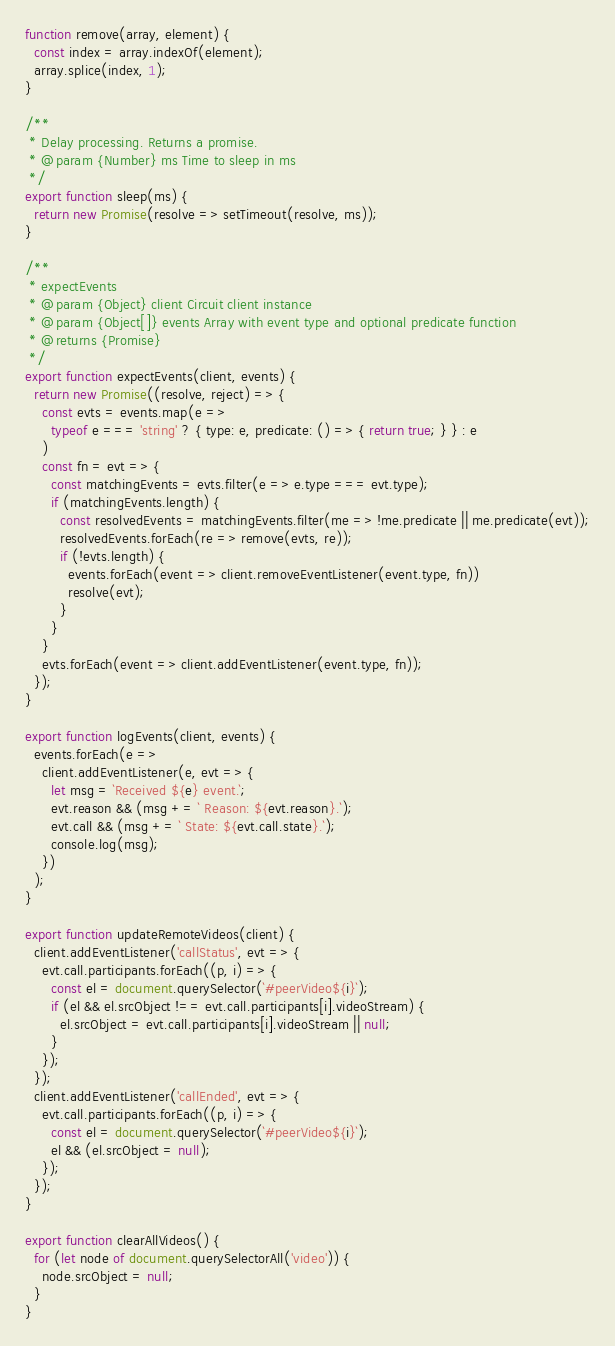Convert code to text. <code><loc_0><loc_0><loc_500><loc_500><_JavaScript_>
function remove(array, element) {
  const index = array.indexOf(element);
  array.splice(index, 1);
}

/**
 * Delay processing. Returns a promise.
 * @param {Number} ms Time to sleep in ms
 */
export function sleep(ms) {
  return new Promise(resolve => setTimeout(resolve, ms));
}

/**
 * expectEvents
 * @param {Object} client Circuit client instance
 * @param {Object[]} events Array with event type and optional predicate function
 * @returns {Promise}
 */
export function expectEvents(client, events) {
  return new Promise((resolve, reject) => {
    const evts = events.map(e =>
      typeof e === 'string' ? { type: e, predicate: () => { return true; } } : e
    )
    const fn = evt => {
      const matchingEvents = evts.filter(e => e.type === evt.type);
      if (matchingEvents.length) {
        const resolvedEvents = matchingEvents.filter(me => !me.predicate || me.predicate(evt));
        resolvedEvents.forEach(re => remove(evts, re));
        if (!evts.length) {
          events.forEach(event => client.removeEventListener(event.type, fn))
          resolve(evt);
        }
      }
    }
    evts.forEach(event => client.addEventListener(event.type, fn));
  });
}

export function logEvents(client, events) {
  events.forEach(e =>
    client.addEventListener(e, evt => {
      let msg = `Received ${e} event.`;
      evt.reason && (msg += ` Reason: ${evt.reason}.`);
      evt.call && (msg += ` State: ${evt.call.state}.`);
      console.log(msg);
    })
  );
}

export function updateRemoteVideos(client) {
  client.addEventListener('callStatus', evt => {
    evt.call.participants.forEach((p, i) => {
      const el = document.querySelector(`#peerVideo${i}`);
      if (el && el.srcObject !== evt.call.participants[i].videoStream) {
        el.srcObject = evt.call.participants[i].videoStream || null;
      }
    });
  });
  client.addEventListener('callEnded', evt => {
    evt.call.participants.forEach((p, i) => {
      const el = document.querySelector(`#peerVideo${i}`);
      el && (el.srcObject = null);
    });
  });
}

export function clearAllVideos() {
  for (let node of document.querySelectorAll('video')) {
    node.srcObject = null;
  }
}
</code> 